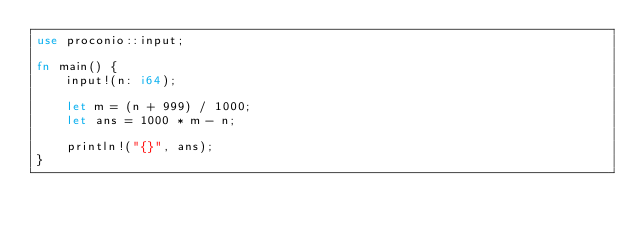<code> <loc_0><loc_0><loc_500><loc_500><_Rust_>use proconio::input;

fn main() {
    input!(n: i64);

    let m = (n + 999) / 1000;
    let ans = 1000 * m - n;

    println!("{}", ans);
}
</code> 